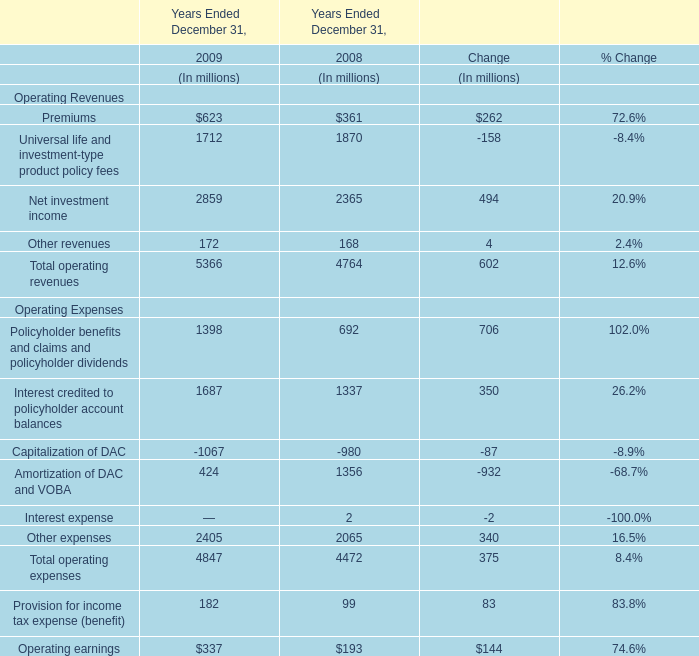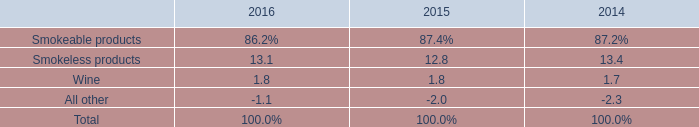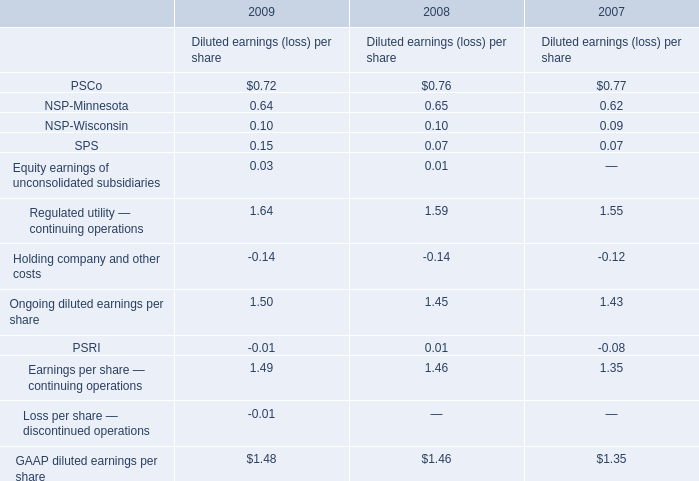In the year with the most Premiums what is the growth rate of Net investment income? 
Computations: ((2859 - 2365) / 2365)
Answer: 0.20888. 